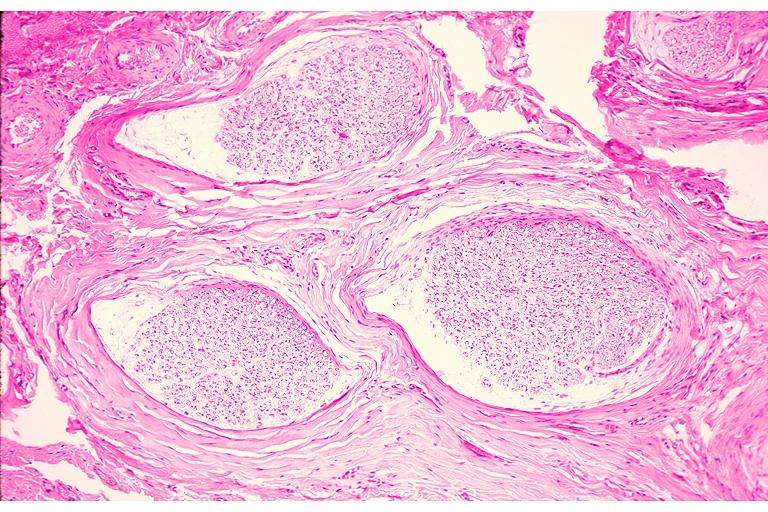what does this image show?
Answer the question using a single word or phrase. Traumatic neuroma 